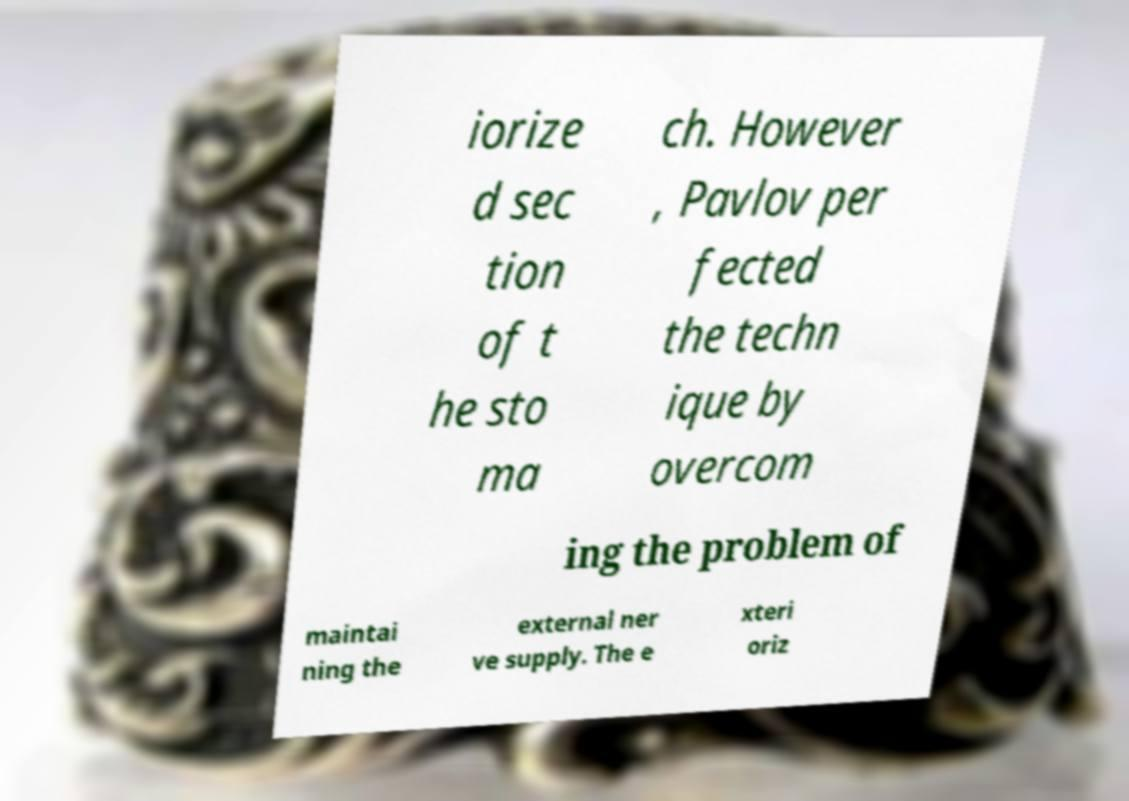Please identify and transcribe the text found in this image. iorize d sec tion of t he sto ma ch. However , Pavlov per fected the techn ique by overcom ing the problem of maintai ning the external ner ve supply. The e xteri oriz 